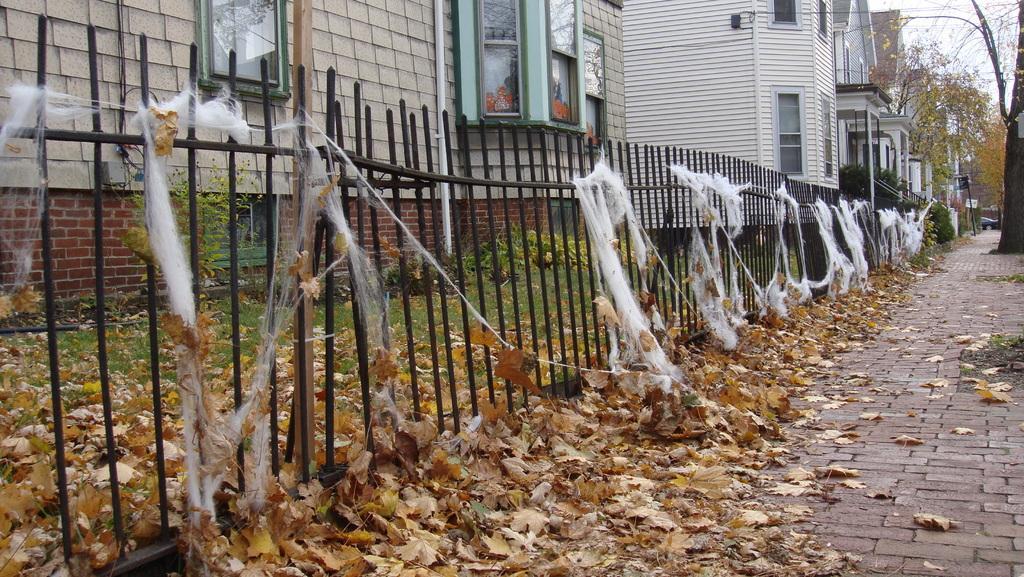How would you summarize this image in a sentence or two? In this image on the left side there is a railing and there is a cotton and some dry leaves and plants, at the bottom there is walkway and there are some buildings, trees, vehicle and pole in the background. At the top of the image there is sky. 